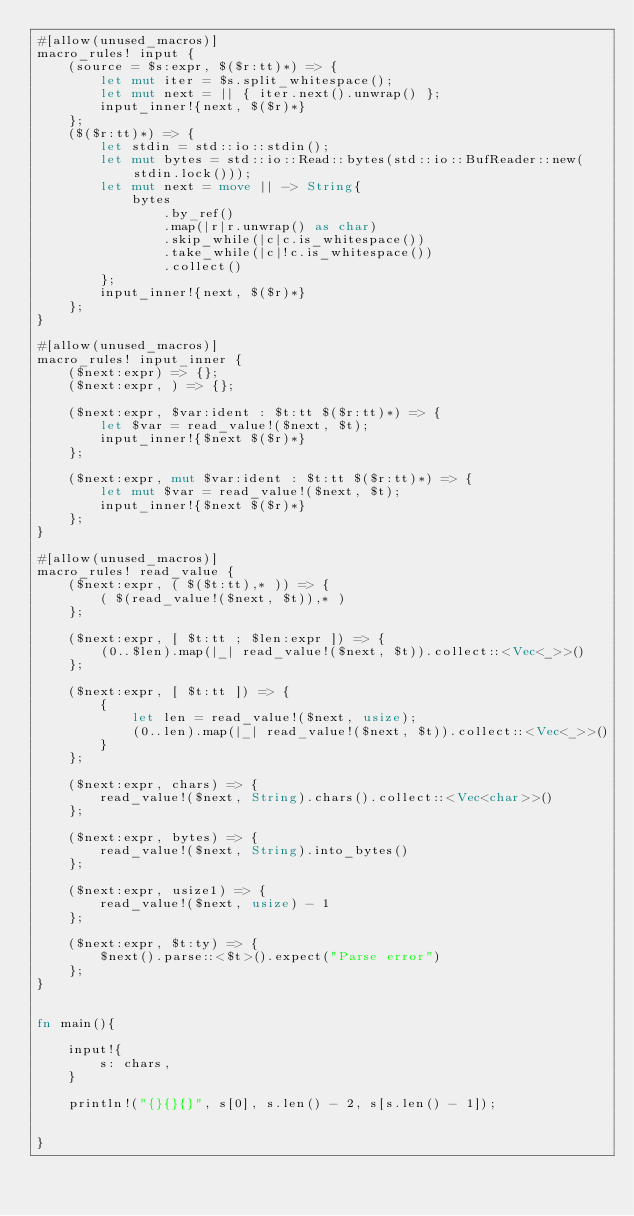<code> <loc_0><loc_0><loc_500><loc_500><_Rust_>#[allow(unused_macros)]
macro_rules! input {
    (source = $s:expr, $($r:tt)*) => {
        let mut iter = $s.split_whitespace();
        let mut next = || { iter.next().unwrap() };
        input_inner!{next, $($r)*}
    };
    ($($r:tt)*) => {
        let stdin = std::io::stdin();
        let mut bytes = std::io::Read::bytes(std::io::BufReader::new(stdin.lock()));
        let mut next = move || -> String{
            bytes
                .by_ref()
                .map(|r|r.unwrap() as char)
                .skip_while(|c|c.is_whitespace())
                .take_while(|c|!c.is_whitespace())
                .collect()
        };
        input_inner!{next, $($r)*}
    };
}

#[allow(unused_macros)]
macro_rules! input_inner {
    ($next:expr) => {};
    ($next:expr, ) => {};

    ($next:expr, $var:ident : $t:tt $($r:tt)*) => {
        let $var = read_value!($next, $t);
        input_inner!{$next $($r)*}
    };

    ($next:expr, mut $var:ident : $t:tt $($r:tt)*) => {
        let mut $var = read_value!($next, $t);
        input_inner!{$next $($r)*}
    };
}

#[allow(unused_macros)]
macro_rules! read_value {
    ($next:expr, ( $($t:tt),* )) => {
        ( $(read_value!($next, $t)),* )
    };

    ($next:expr, [ $t:tt ; $len:expr ]) => {
        (0..$len).map(|_| read_value!($next, $t)).collect::<Vec<_>>()
    };

    ($next:expr, [ $t:tt ]) => {
        {
            let len = read_value!($next, usize);
            (0..len).map(|_| read_value!($next, $t)).collect::<Vec<_>>()
        }
    };

    ($next:expr, chars) => {
        read_value!($next, String).chars().collect::<Vec<char>>()
    };

    ($next:expr, bytes) => {
        read_value!($next, String).into_bytes()
    };

    ($next:expr, usize1) => {
        read_value!($next, usize) - 1
    };

    ($next:expr, $t:ty) => {
        $next().parse::<$t>().expect("Parse error")
    };
}


fn main(){

    input!{
        s: chars,
    }

    println!("{}{}{}", s[0], s.len() - 2, s[s.len() - 1]);


}</code> 